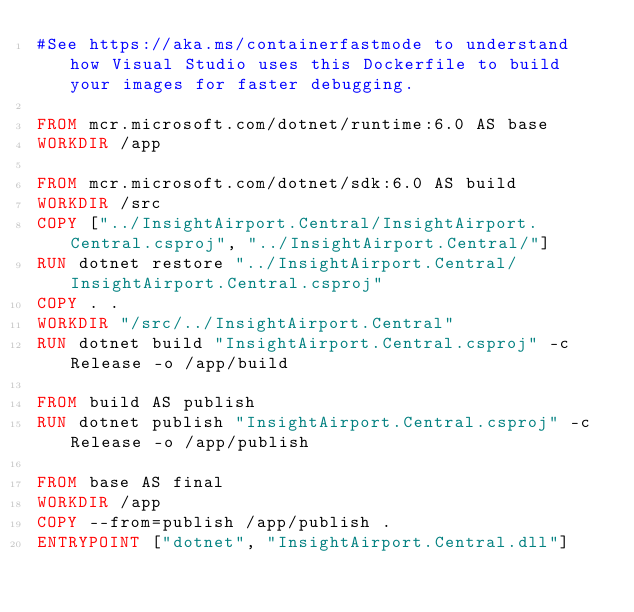Convert code to text. <code><loc_0><loc_0><loc_500><loc_500><_Dockerfile_>#See https://aka.ms/containerfastmode to understand how Visual Studio uses this Dockerfile to build your images for faster debugging.

FROM mcr.microsoft.com/dotnet/runtime:6.0 AS base
WORKDIR /app

FROM mcr.microsoft.com/dotnet/sdk:6.0 AS build
WORKDIR /src
COPY ["../InsightAirport.Central/InsightAirport.Central.csproj", "../InsightAirport.Central/"]
RUN dotnet restore "../InsightAirport.Central/InsightAirport.Central.csproj"
COPY . .
WORKDIR "/src/../InsightAirport.Central"
RUN dotnet build "InsightAirport.Central.csproj" -c Release -o /app/build

FROM build AS publish
RUN dotnet publish "InsightAirport.Central.csproj" -c Release -o /app/publish

FROM base AS final
WORKDIR /app
COPY --from=publish /app/publish .
ENTRYPOINT ["dotnet", "InsightAirport.Central.dll"]</code> 